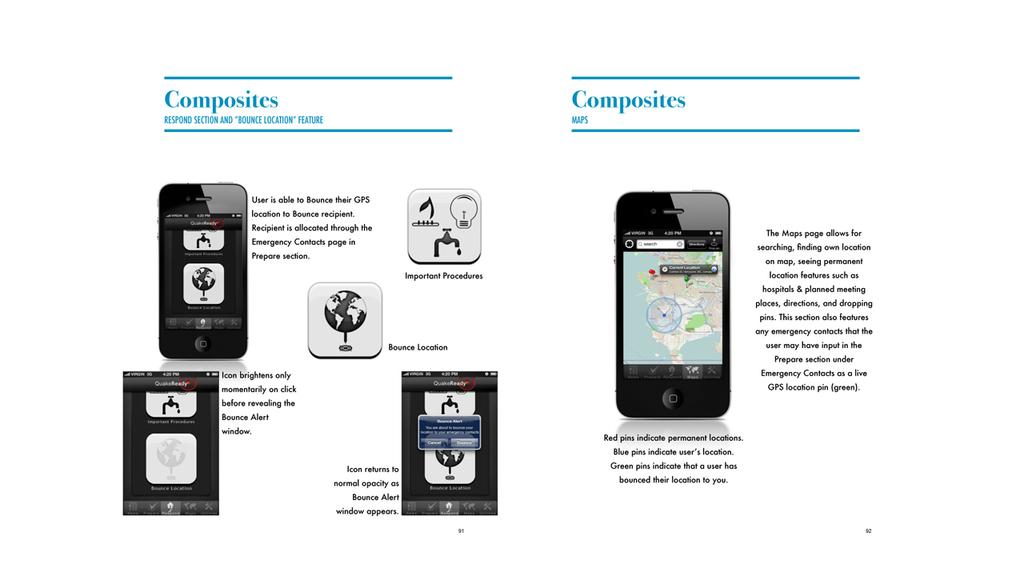<image>
Summarize the visual content of the image. a group of square items and one with composites written on it 